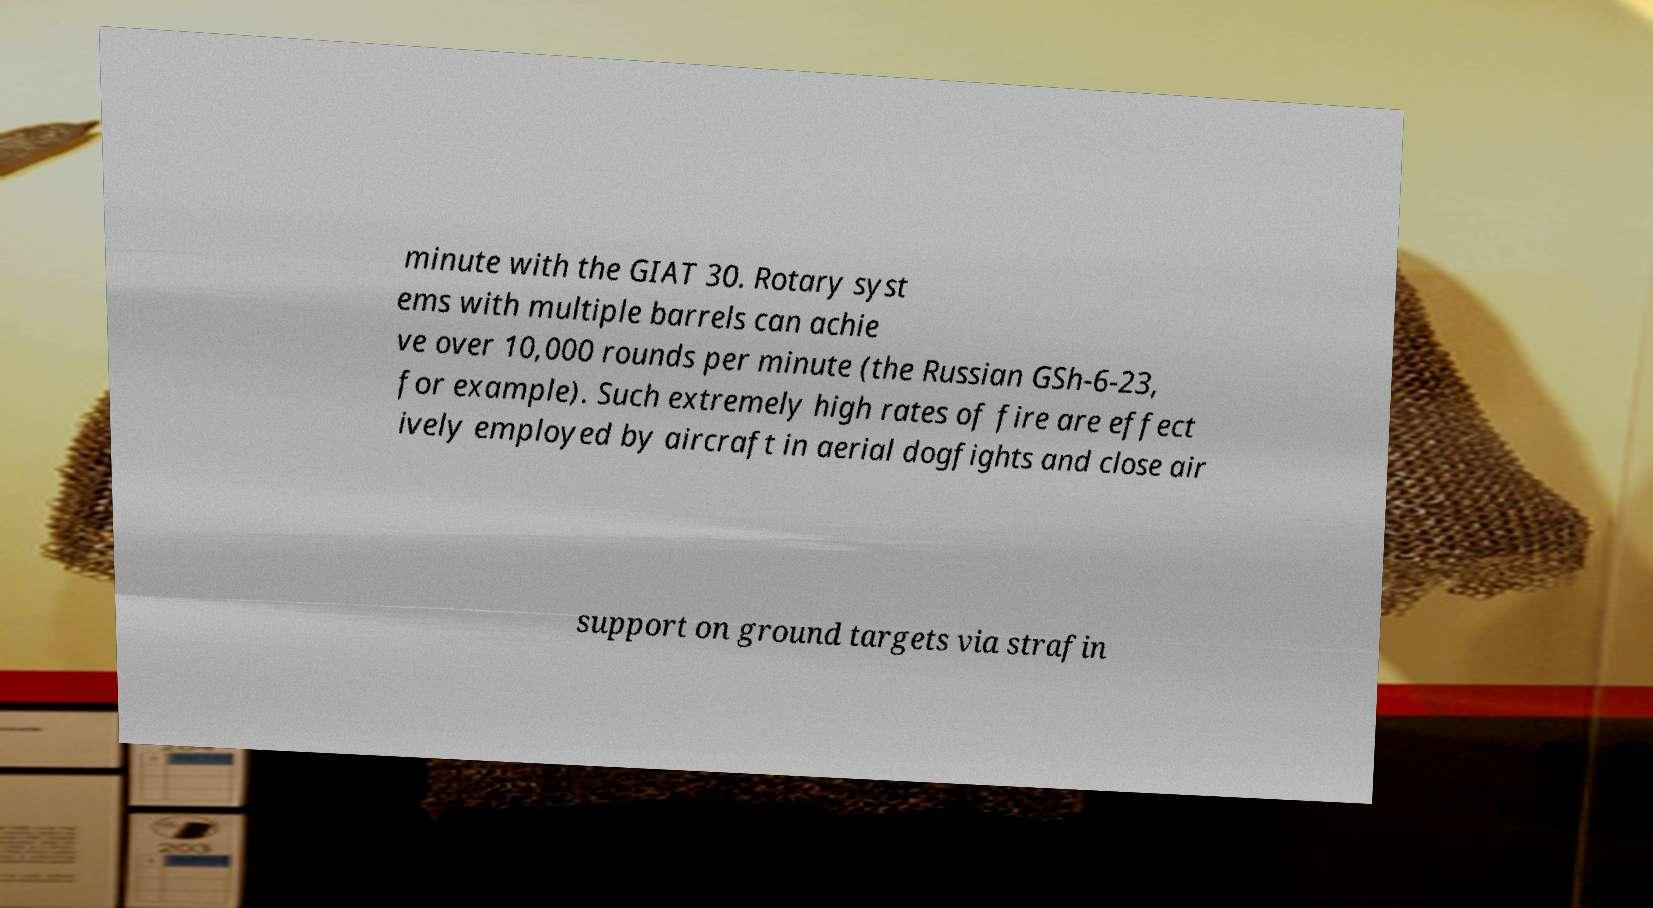There's text embedded in this image that I need extracted. Can you transcribe it verbatim? minute with the GIAT 30. Rotary syst ems with multiple barrels can achie ve over 10,000 rounds per minute (the Russian GSh-6-23, for example). Such extremely high rates of fire are effect ively employed by aircraft in aerial dogfights and close air support on ground targets via strafin 